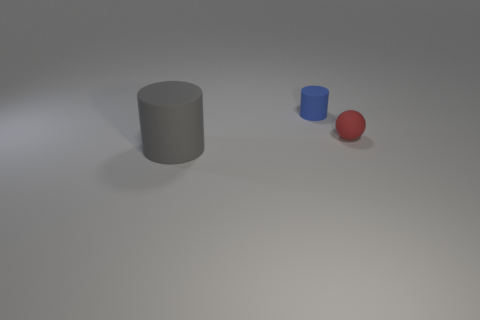There is a small thing that is left of the rubber thing right of the small blue cylinder; what is its shape? The small object located to the left of the rubbery material, which is right of the small blue cylinder, appears to be a sphere. 